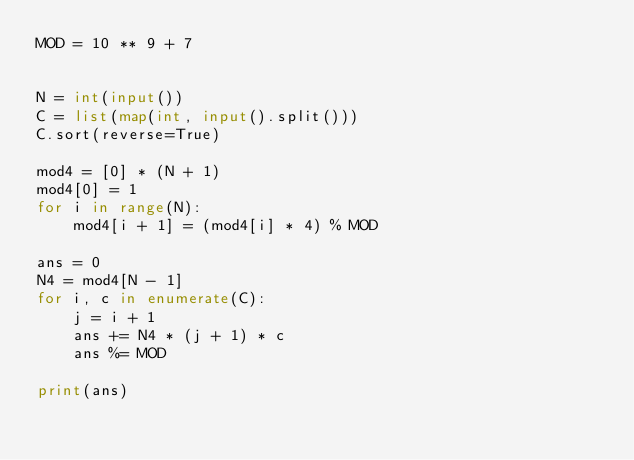Convert code to text. <code><loc_0><loc_0><loc_500><loc_500><_Python_>MOD = 10 ** 9 + 7


N = int(input())
C = list(map(int, input().split()))
C.sort(reverse=True)

mod4 = [0] * (N + 1)
mod4[0] = 1
for i in range(N):
    mod4[i + 1] = (mod4[i] * 4) % MOD

ans = 0
N4 = mod4[N - 1]
for i, c in enumerate(C):
    j = i + 1
    ans += N4 * (j + 1) * c
    ans %= MOD

print(ans)
</code> 